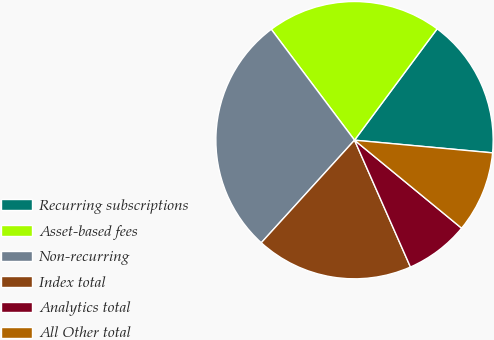Convert chart to OTSL. <chart><loc_0><loc_0><loc_500><loc_500><pie_chart><fcel>Recurring subscriptions<fcel>Asset-based fees<fcel>Non-recurring<fcel>Index total<fcel>Analytics total<fcel>All Other total<nl><fcel>16.3%<fcel>20.41%<fcel>28.01%<fcel>18.35%<fcel>7.44%<fcel>9.49%<nl></chart> 